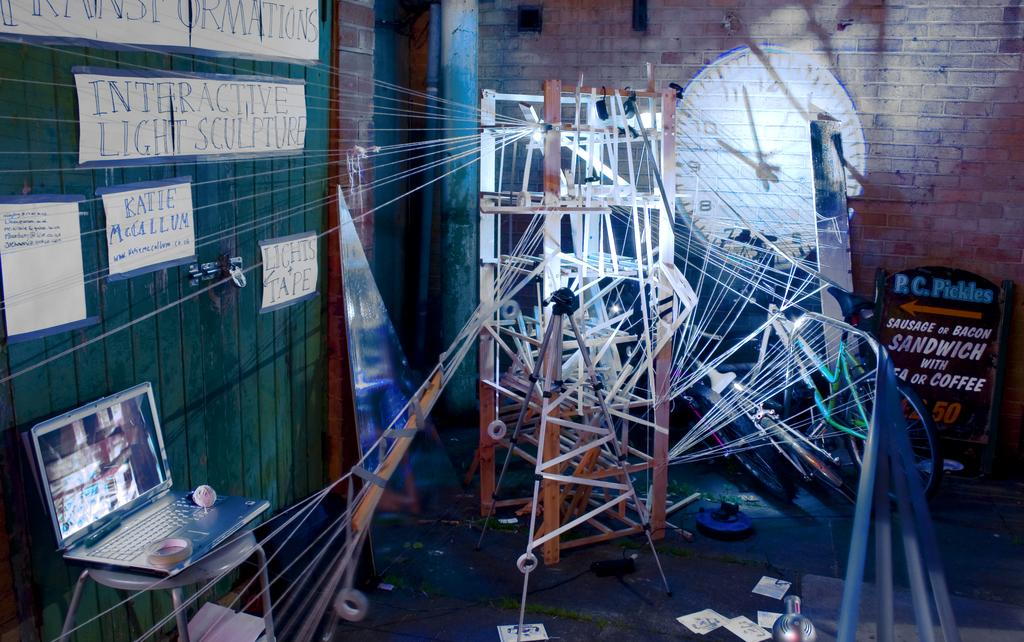<image>
Offer a succinct explanation of the picture presented. Sign that says P.C. Pickles in blue under a painting of a clock. 